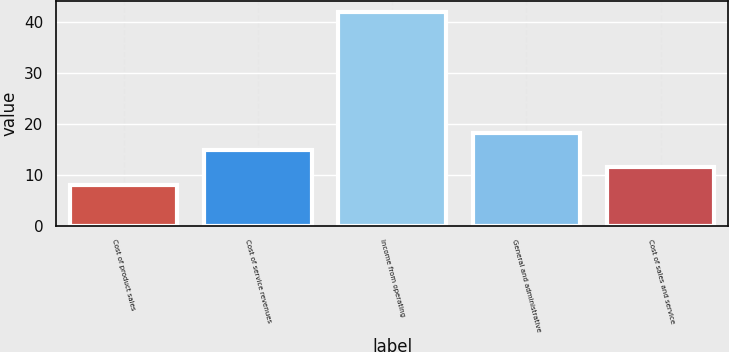<chart> <loc_0><loc_0><loc_500><loc_500><bar_chart><fcel>Cost of product sales<fcel>Cost of service revenues<fcel>Income from operating<fcel>General and administrative<fcel>Cost of sales and service<nl><fcel>8<fcel>14.8<fcel>42<fcel>18.2<fcel>11.4<nl></chart> 